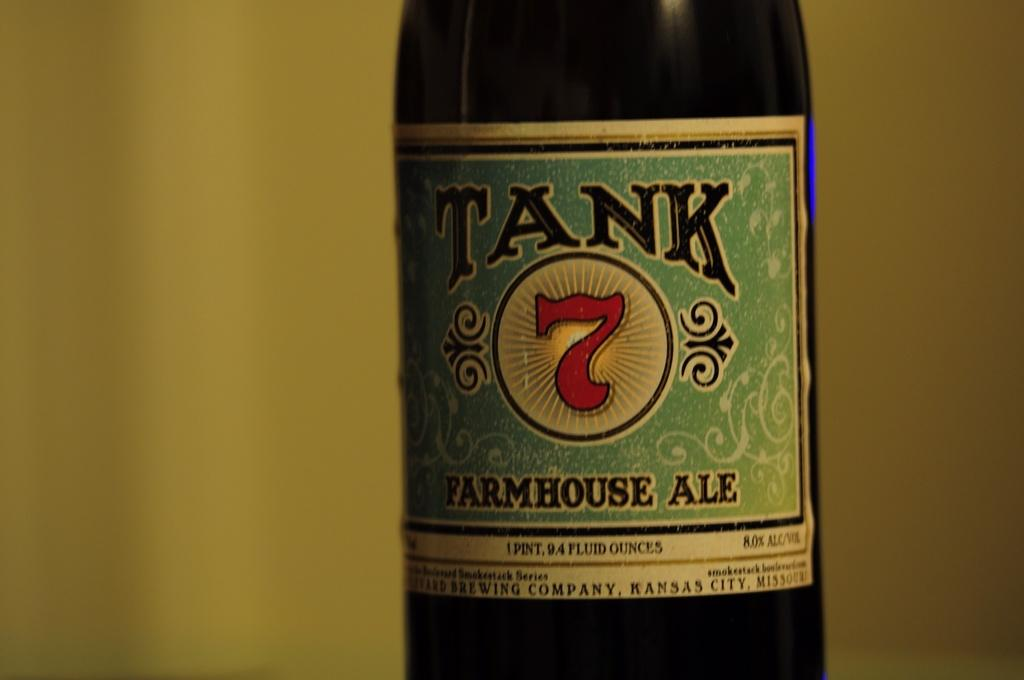Provide a one-sentence caption for the provided image. Tank is a type of Farmhouse Ale that is drinkable. 